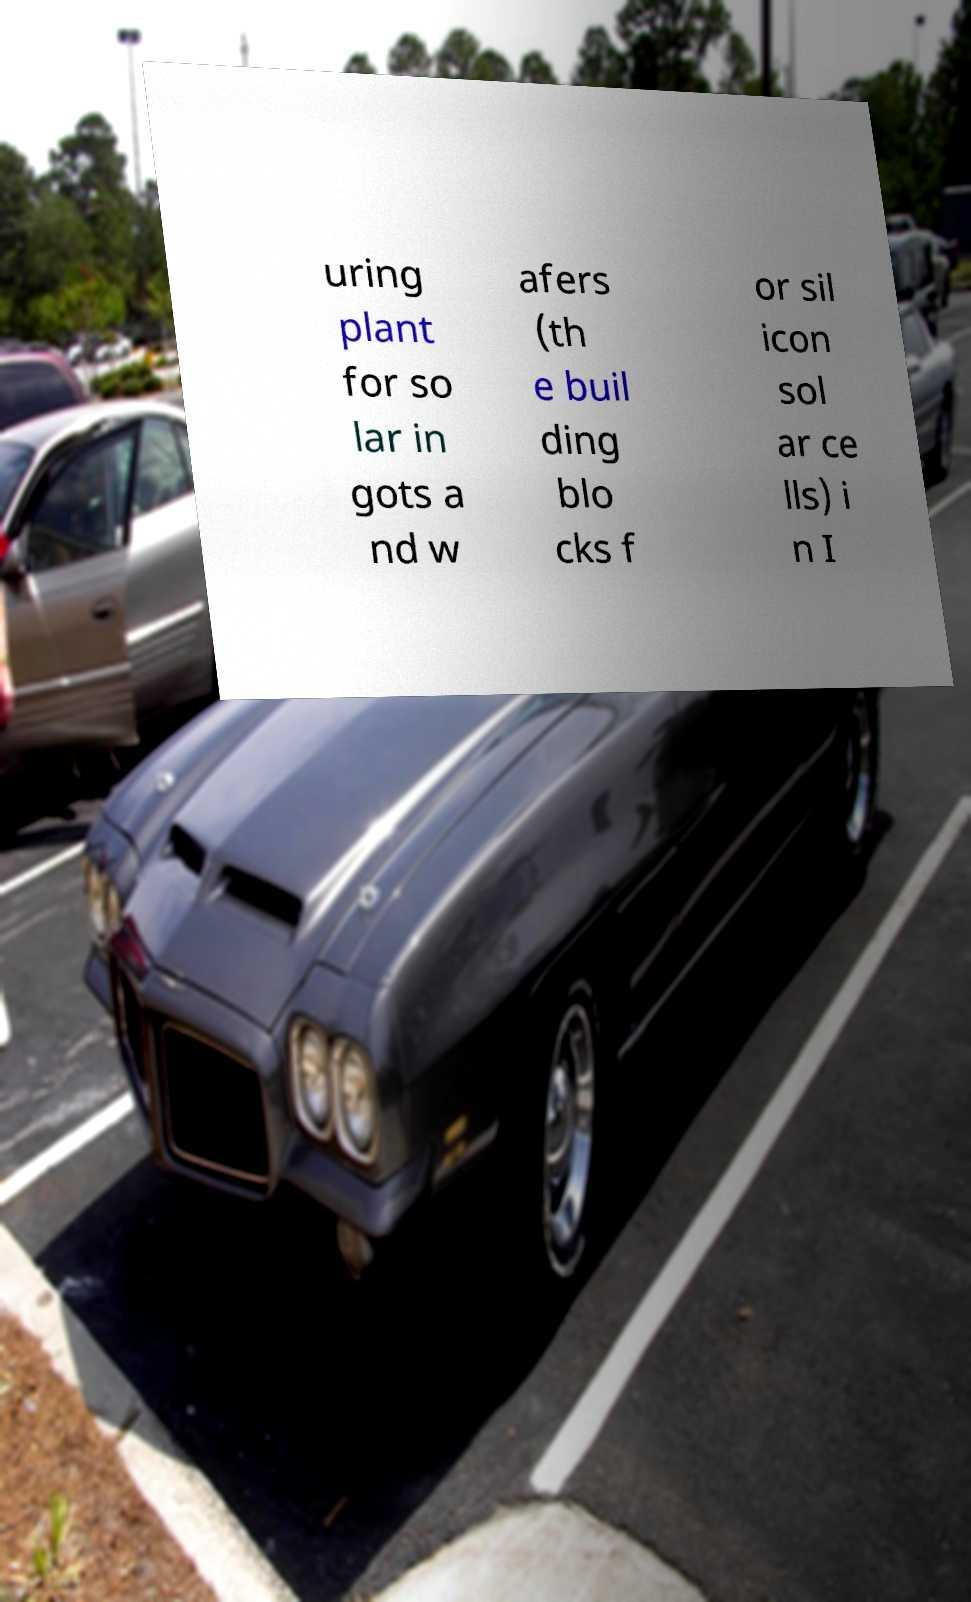Can you accurately transcribe the text from the provided image for me? uring plant for so lar in gots a nd w afers (th e buil ding blo cks f or sil icon sol ar ce lls) i n I 